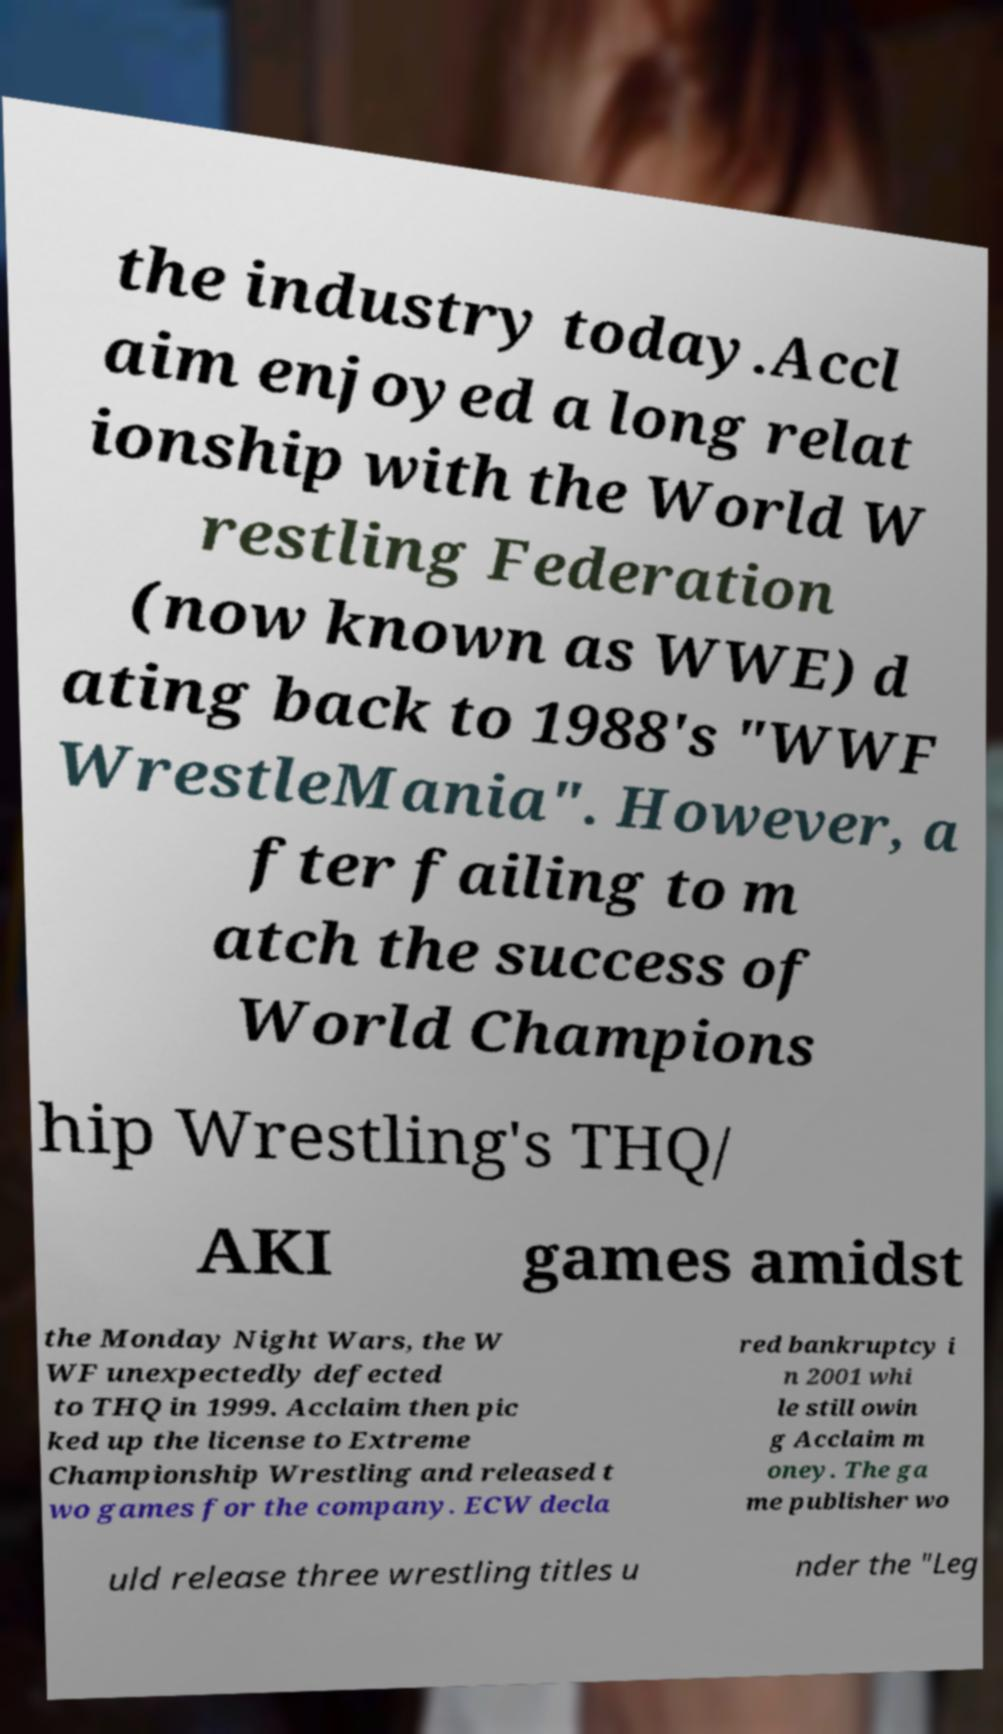There's text embedded in this image that I need extracted. Can you transcribe it verbatim? the industry today.Accl aim enjoyed a long relat ionship with the World W restling Federation (now known as WWE) d ating back to 1988's "WWF WrestleMania". However, a fter failing to m atch the success of World Champions hip Wrestling's THQ/ AKI games amidst the Monday Night Wars, the W WF unexpectedly defected to THQ in 1999. Acclaim then pic ked up the license to Extreme Championship Wrestling and released t wo games for the company. ECW decla red bankruptcy i n 2001 whi le still owin g Acclaim m oney. The ga me publisher wo uld release three wrestling titles u nder the "Leg 